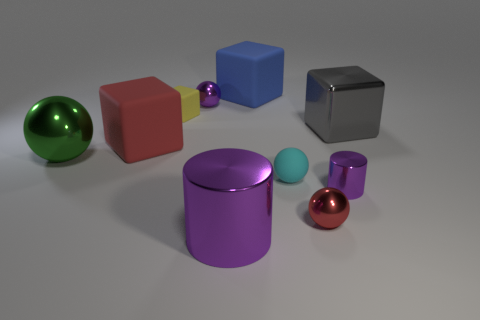Subtract all big green metal spheres. How many spheres are left? 3 Subtract all blue cubes. How many cubes are left? 3 Subtract 1 cylinders. How many cylinders are left? 1 Subtract all cylinders. How many objects are left? 8 Subtract all red cylinders. Subtract all red blocks. How many cylinders are left? 2 Subtract all tiny cyan things. Subtract all small rubber balls. How many objects are left? 8 Add 9 small yellow matte blocks. How many small yellow matte blocks are left? 10 Add 6 big matte cubes. How many big matte cubes exist? 8 Subtract 0 brown cylinders. How many objects are left? 10 